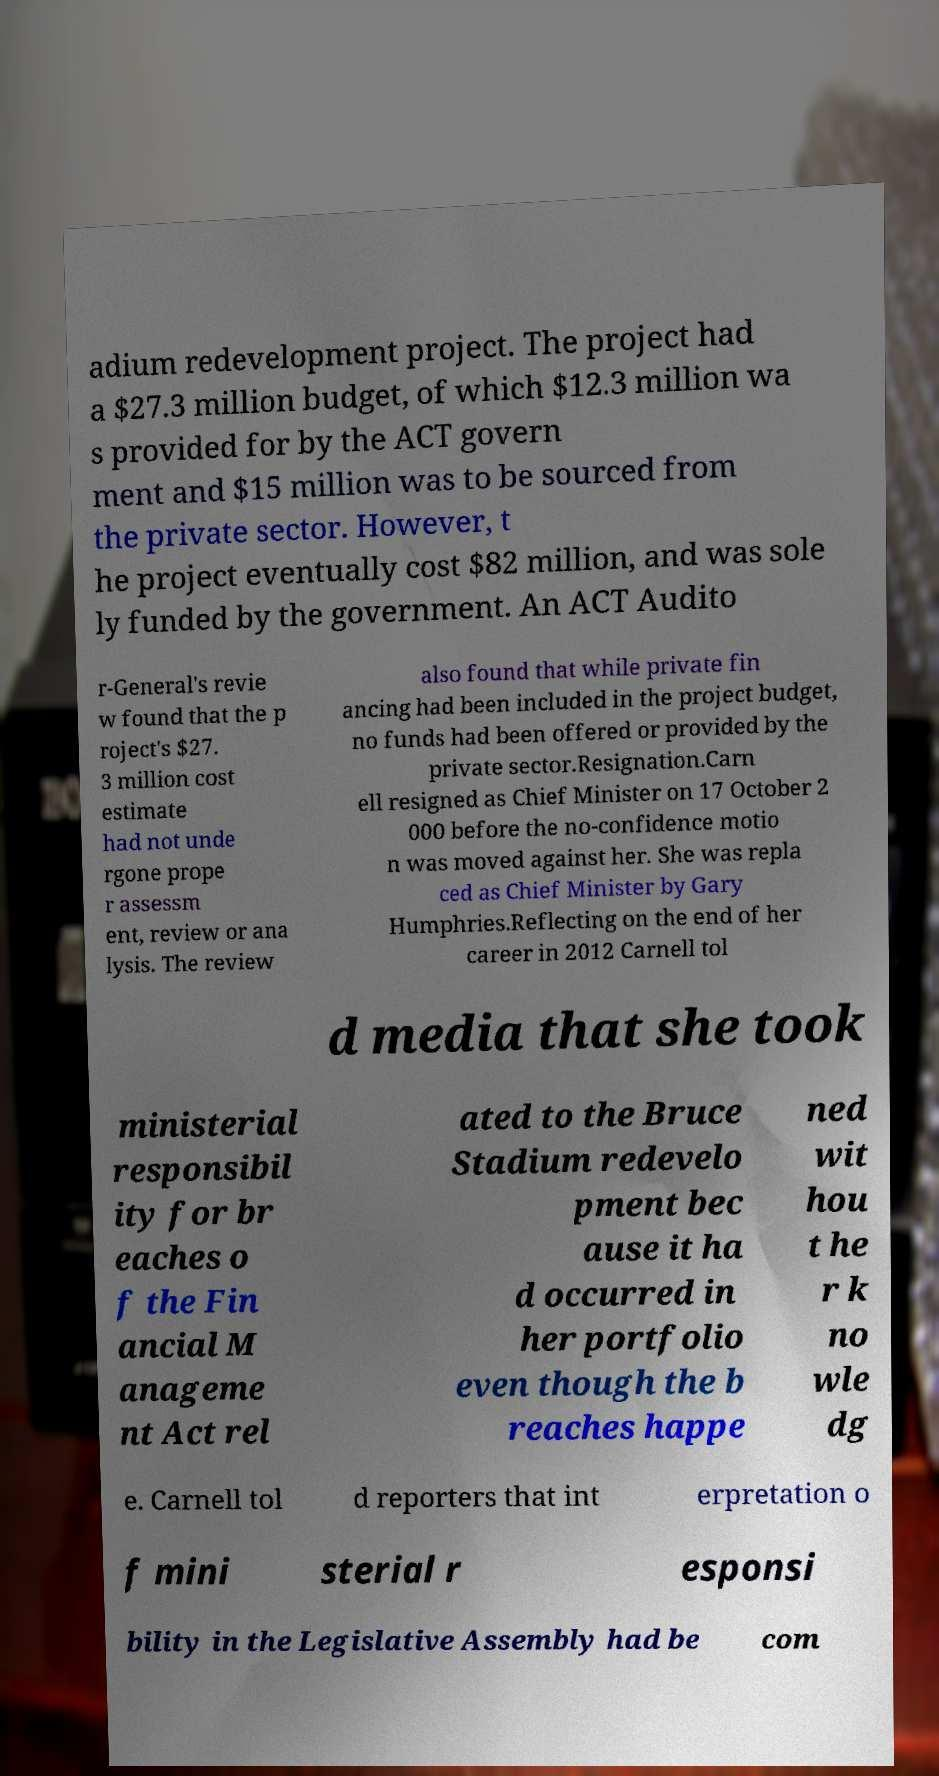Can you accurately transcribe the text from the provided image for me? adium redevelopment project. The project had a $27.3 million budget, of which $12.3 million wa s provided for by the ACT govern ment and $15 million was to be sourced from the private sector. However, t he project eventually cost $82 million, and was sole ly funded by the government. An ACT Audito r-General's revie w found that the p roject's $27. 3 million cost estimate had not unde rgone prope r assessm ent, review or ana lysis. The review also found that while private fin ancing had been included in the project budget, no funds had been offered or provided by the private sector.Resignation.Carn ell resigned as Chief Minister on 17 October 2 000 before the no-confidence motio n was moved against her. She was repla ced as Chief Minister by Gary Humphries.Reflecting on the end of her career in 2012 Carnell tol d media that she took ministerial responsibil ity for br eaches o f the Fin ancial M anageme nt Act rel ated to the Bruce Stadium redevelo pment bec ause it ha d occurred in her portfolio even though the b reaches happe ned wit hou t he r k no wle dg e. Carnell tol d reporters that int erpretation o f mini sterial r esponsi bility in the Legislative Assembly had be com 